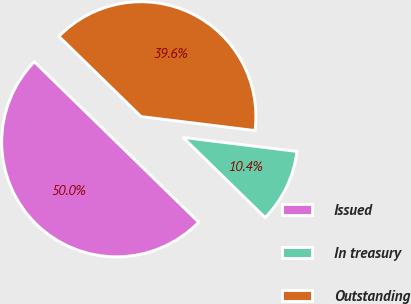Convert chart. <chart><loc_0><loc_0><loc_500><loc_500><pie_chart><fcel>Issued<fcel>In treasury<fcel>Outstanding<nl><fcel>50.0%<fcel>10.36%<fcel>39.64%<nl></chart> 